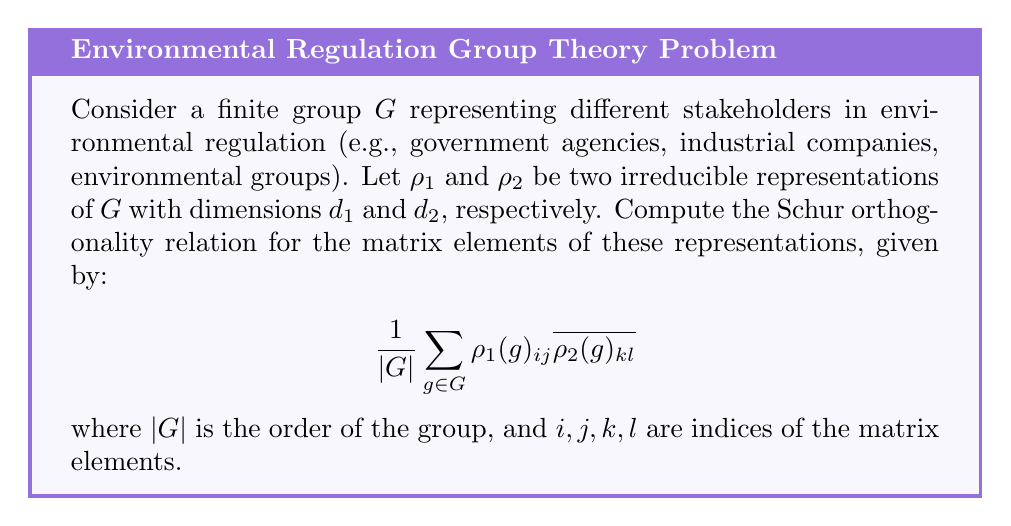Help me with this question. To solve this problem, we'll follow these steps:

1) Recall the Schur orthogonality relations for finite groups:

   For two irreducible representations $\rho_1$ and $\rho_2$ of a finite group $G$:

   $$\frac{1}{|G|} \sum_{g \in G} \rho_1(g)_{ij} \overline{\rho_2(g)_{kl}} = \frac{1}{d_1} \delta_{\rho_1, \rho_2} \delta_{ik} \delta_{jl}$$

   where $\delta$ is the Kronecker delta function.

2) Interpret the result:

   - If $\rho_1 \neq \rho_2$, the sum is zero.
   - If $\rho_1 = \rho_2$:
     - If $i \neq k$ or $j \neq l$, the sum is zero.
     - If $i = k$ and $j = l$, the sum equals $\frac{1}{d_1}$.

3) In the context of environmental regulations:
   - Different representations could correspond to different perspectives on regulation (e.g., economic, environmental, social).
   - The orthogonality relation suggests that these perspectives are independent when considered across all stakeholders.
   - The $\frac{1}{d_1}$ factor for matching representations and indices indicates a normalization based on the dimension of the representation.

Therefore, the Schur orthogonality relation for this scenario is:

$$\frac{1}{|G|} \sum_{g \in G} \rho_1(g)_{ij} \overline{\rho_2(g)_{kl}} = \frac{1}{d_1} \delta_{\rho_1, \rho_2} \delta_{ik} \delta_{jl}$$
Answer: $\frac{1}{d_1} \delta_{\rho_1, \rho_2} \delta_{ik} \delta_{jl}$ 